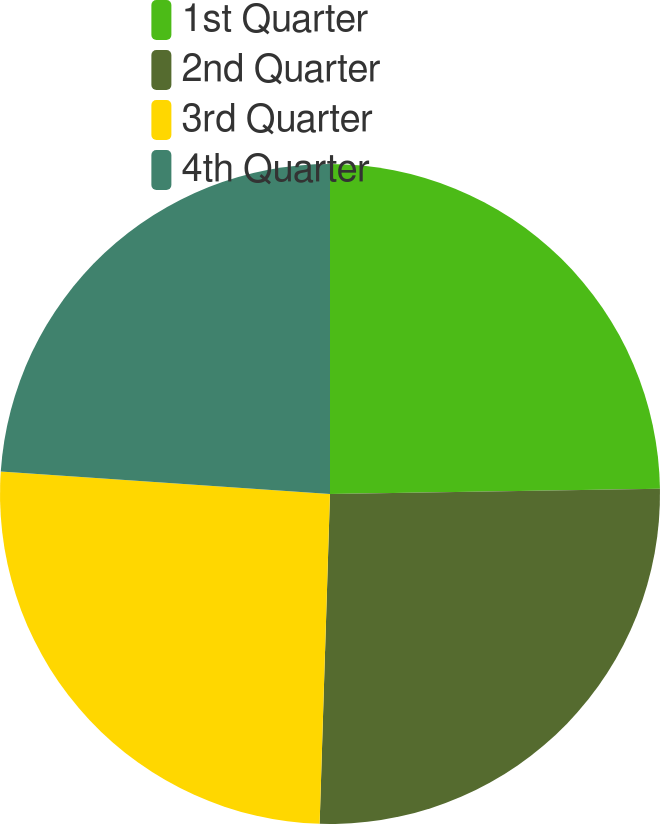Convert chart. <chart><loc_0><loc_0><loc_500><loc_500><pie_chart><fcel>1st Quarter<fcel>2nd Quarter<fcel>3rd Quarter<fcel>4th Quarter<nl><fcel>24.75%<fcel>25.75%<fcel>25.58%<fcel>23.92%<nl></chart> 